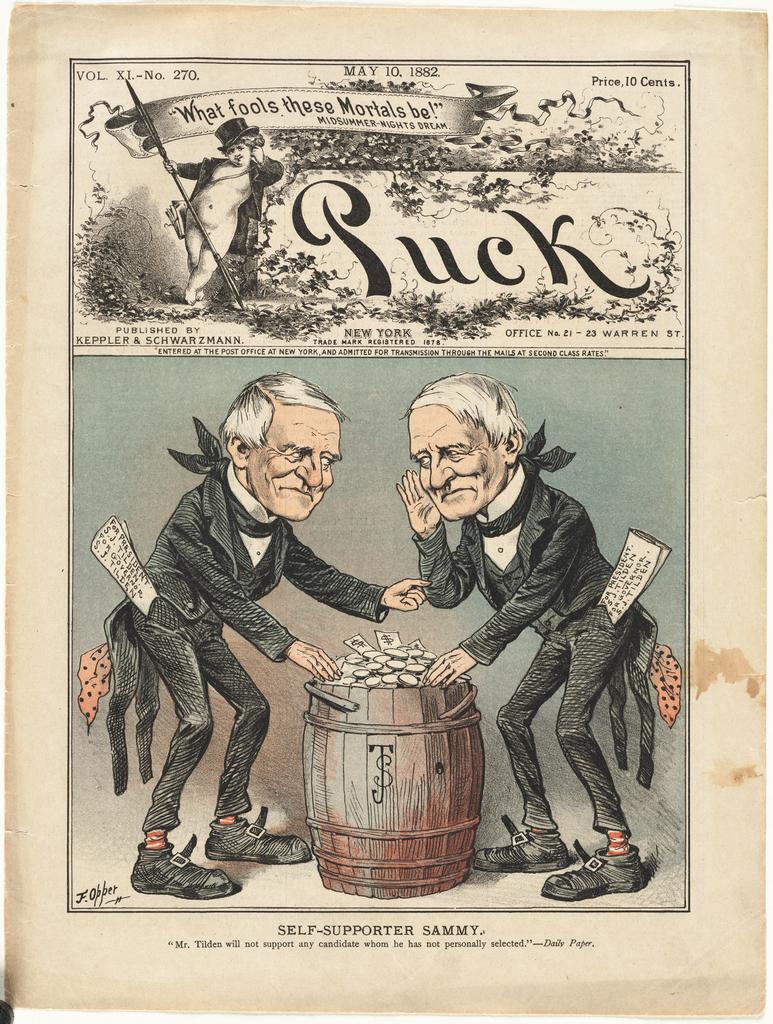Who are these mortals that they are calling fools?
Your response must be concise. Unanswerable. When was this published?
Give a very brief answer. May 10, 1882. 